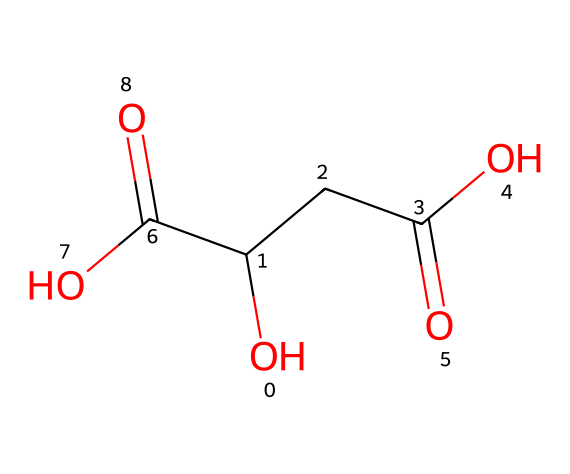how many carboxylic acid groups are in malic acid? The SMILES representation shows two -COOH groups in the formula, indicating the presence of two carboxylic acid groups.
Answer: two what is the main functional group in malic acid? The presence of two -COOH (carboxylic acid) groups indicates that carboxylic acid is the main functional group present in this molecule.
Answer: carboxylic acid how many hydroxyl groups are in malic acid? From the SMILES representation, there are two -OH groups indicated in the structure, which clarifies that there are two hydroxyl groups present.
Answer: two what type of acid is malic acid? Given its structure, malic acid can be classified as a dicarboxylic acid because it has two carboxylic acid groups.
Answer: dicarboxylic acid what impact might malic acid have in pet-safe cleaning solutions? Malic acid is known for its natural cleaning properties, which can help in removing stains and mineral deposits without being harmful to pets.
Answer: natural cleaning properties how does the presence of hydroxyl groups affect malic acid's solubility? The hydroxyl groups in malic acid are polar, which increases the molecule's overall polarity and solubility in water, aiding in its application for cleaning solutions.
Answer: increases solubility 